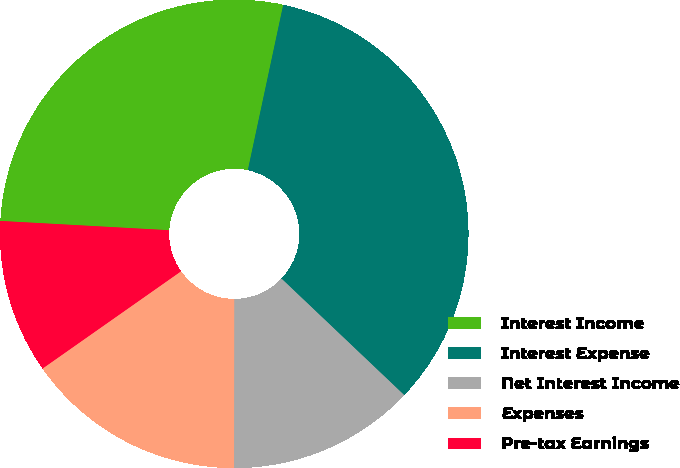Convert chart to OTSL. <chart><loc_0><loc_0><loc_500><loc_500><pie_chart><fcel>Interest Income<fcel>Interest Expense<fcel>Net Interest Income<fcel>Expenses<fcel>Pre-tax Earnings<nl><fcel>27.48%<fcel>33.73%<fcel>12.93%<fcel>15.24%<fcel>10.62%<nl></chart> 